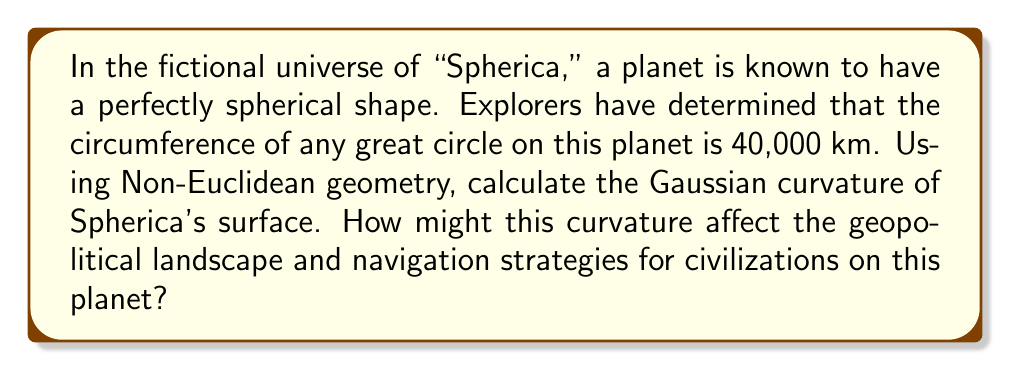Provide a solution to this math problem. To solve this problem, we'll use concepts from Non-Euclidean geometry, specifically for a spherical surface. Let's approach this step-by-step:

1) In Non-Euclidean geometry, the Gaussian curvature (K) of a sphere is constant and given by:

   $$K = \frac{1}{R^2}$$

   where R is the radius of the sphere.

2) We need to find the radius of Spherica. We know that the circumference of any great circle is 40,000 km. The formula for the circumference of a sphere is:

   $$C = 2\pi R$$

3) Let's solve for R:

   $$40,000 = 2\pi R$$
   $$R = \frac{40,000}{2\pi} \approx 6,366.2 \text{ km}$$

4) Now we can calculate the Gaussian curvature:

   $$K = \frac{1}{R^2} = \frac{1}{(6,366.2)^2} \approx 2.468 \times 10^{-8} \text{ km}^{-2}$$

5) Geopolitical and navigational implications:

   a) The positive curvature means that parallel lines will eventually intersect, affecting long-distance travel and territorial boundaries.
   
   b) The sum of angles in a triangle will exceed 180°, impacting surveying and cartography.
   
   c) The shortest path between two points (geodesic) will be an arc, not a straight line, influencing trade routes and military strategies.
   
   d) There will be no true "flat" surfaces, affecting architecture and agriculture.

   e) The entire surface of the planet will be visible from a sufficient height, potentially impacting global communication and surveillance.

[asy]
import geometry;

unitsize(1cm);

pair O=(0,0);
real R=3;
path c=circle(O,R);
draw(c);

label("R", (R/2,0), E);
draw((0,0)--(R,0));

label("Spherica", (0,0));
[/asy]
Answer: $K \approx 2.468 \times 10^{-8} \text{ km}^{-2}$ 